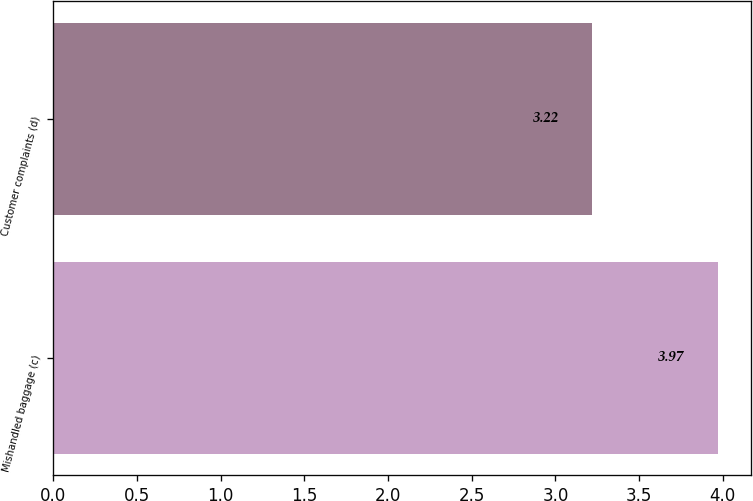Convert chart to OTSL. <chart><loc_0><loc_0><loc_500><loc_500><bar_chart><fcel>Mishandled baggage (c)<fcel>Customer complaints (d)<nl><fcel>3.97<fcel>3.22<nl></chart> 